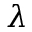Convert formula to latex. <formula><loc_0><loc_0><loc_500><loc_500>\lambda</formula> 